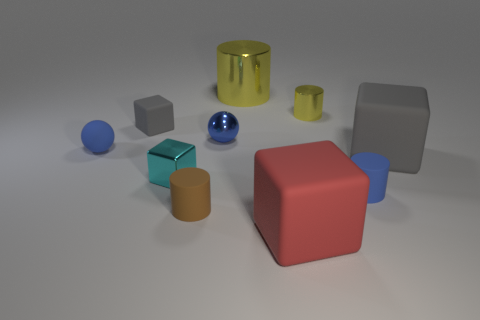There is a tiny blue thing that is to the left of the tiny block behind the small cyan object; what number of yellow metallic objects are in front of it?
Provide a succinct answer. 0. What shape is the metallic object that is left of the red matte block and on the right side of the blue shiny thing?
Give a very brief answer. Cylinder. Is the number of brown things behind the blue cylinder less than the number of small cylinders?
Offer a very short reply. Yes. How many small things are either brown shiny cubes or cyan metal cubes?
Ensure brevity in your answer.  1. What is the size of the brown rubber object?
Give a very brief answer. Small. Is there anything else that is made of the same material as the large red object?
Make the answer very short. Yes. There is a large yellow cylinder; how many yellow cylinders are on the right side of it?
Your answer should be very brief. 1. There is another gray rubber object that is the same shape as the big gray rubber thing; what size is it?
Your response must be concise. Small. What size is the thing that is behind the cyan metallic object and on the right side of the small yellow cylinder?
Make the answer very short. Large. There is a small rubber block; is its color the same as the large thing behind the blue shiny ball?
Offer a terse response. No. 